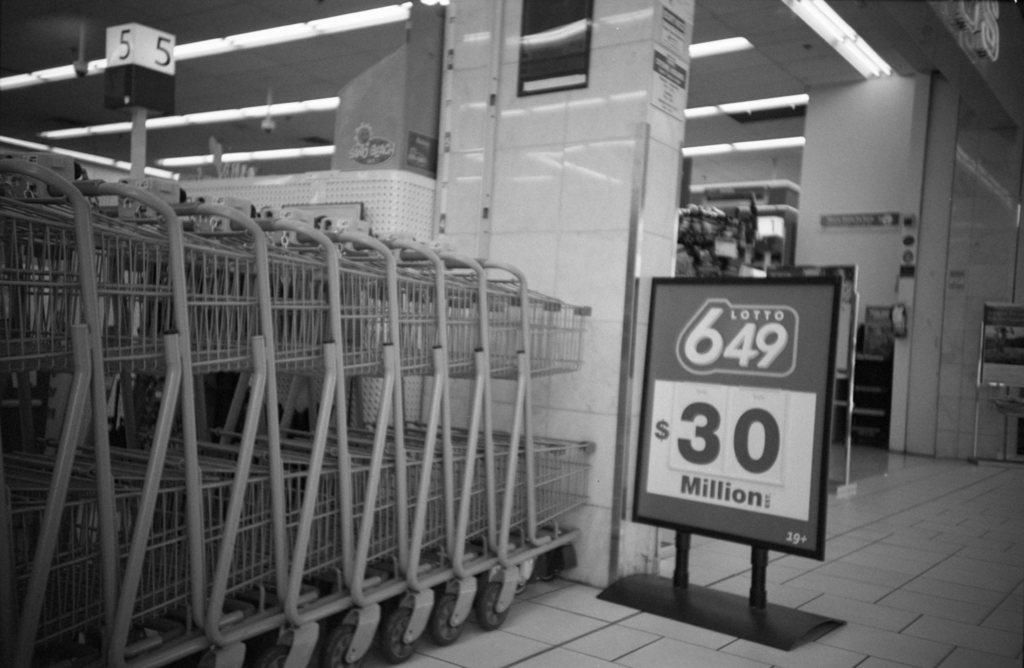<image>
Offer a succinct explanation of the picture presented. Shopping carts next to a sign reading $30 million. 